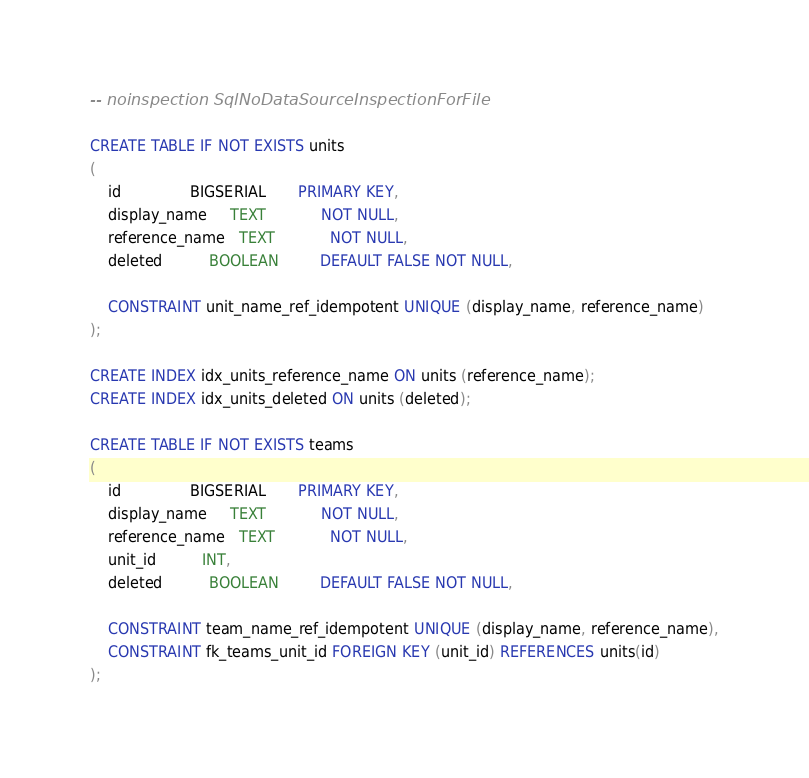<code> <loc_0><loc_0><loc_500><loc_500><_SQL_>-- noinspection SqlNoDataSourceInspectionForFile

CREATE TABLE IF NOT EXISTS units
(
    id               BIGSERIAL       PRIMARY KEY,
    display_name     TEXT            NOT NULL,
    reference_name   TEXT            NOT NULL,
    deleted          BOOLEAN         DEFAULT FALSE NOT NULL,

    CONSTRAINT unit_name_ref_idempotent UNIQUE (display_name, reference_name)
);

CREATE INDEX idx_units_reference_name ON units (reference_name);
CREATE INDEX idx_units_deleted ON units (deleted);

CREATE TABLE IF NOT EXISTS teams
(
    id               BIGSERIAL       PRIMARY KEY,
    display_name     TEXT            NOT NULL,
    reference_name   TEXT            NOT NULL,
    unit_id          INT,
    deleted          BOOLEAN         DEFAULT FALSE NOT NULL,

    CONSTRAINT team_name_ref_idempotent UNIQUE (display_name, reference_name),
    CONSTRAINT fk_teams_unit_id FOREIGN KEY (unit_id) REFERENCES units(id)
);
</code> 